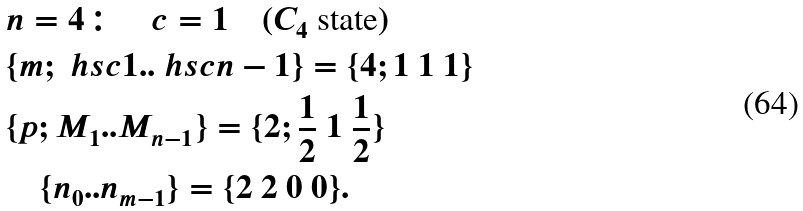Convert formula to latex. <formula><loc_0><loc_0><loc_500><loc_500>& n = 4 \colon \quad c = 1 \quad ( C _ { 4 } \text { state} ) \\ & \{ m ; \ h s c { 1 } . . \ h s c { n - 1 } \} = \{ 4 ; 1 \ 1 \ 1 \} \\ & \{ p ; M _ { 1 } . . M _ { n - 1 } \} = \{ 2 ; \frac { 1 } { 2 } \ 1 \ \frac { 1 } { 2 } \} \\ & \quad \{ n _ { 0 } . . n _ { m - 1 } \} = \{ 2 \ 2 \ 0 \ 0 \} .</formula> 